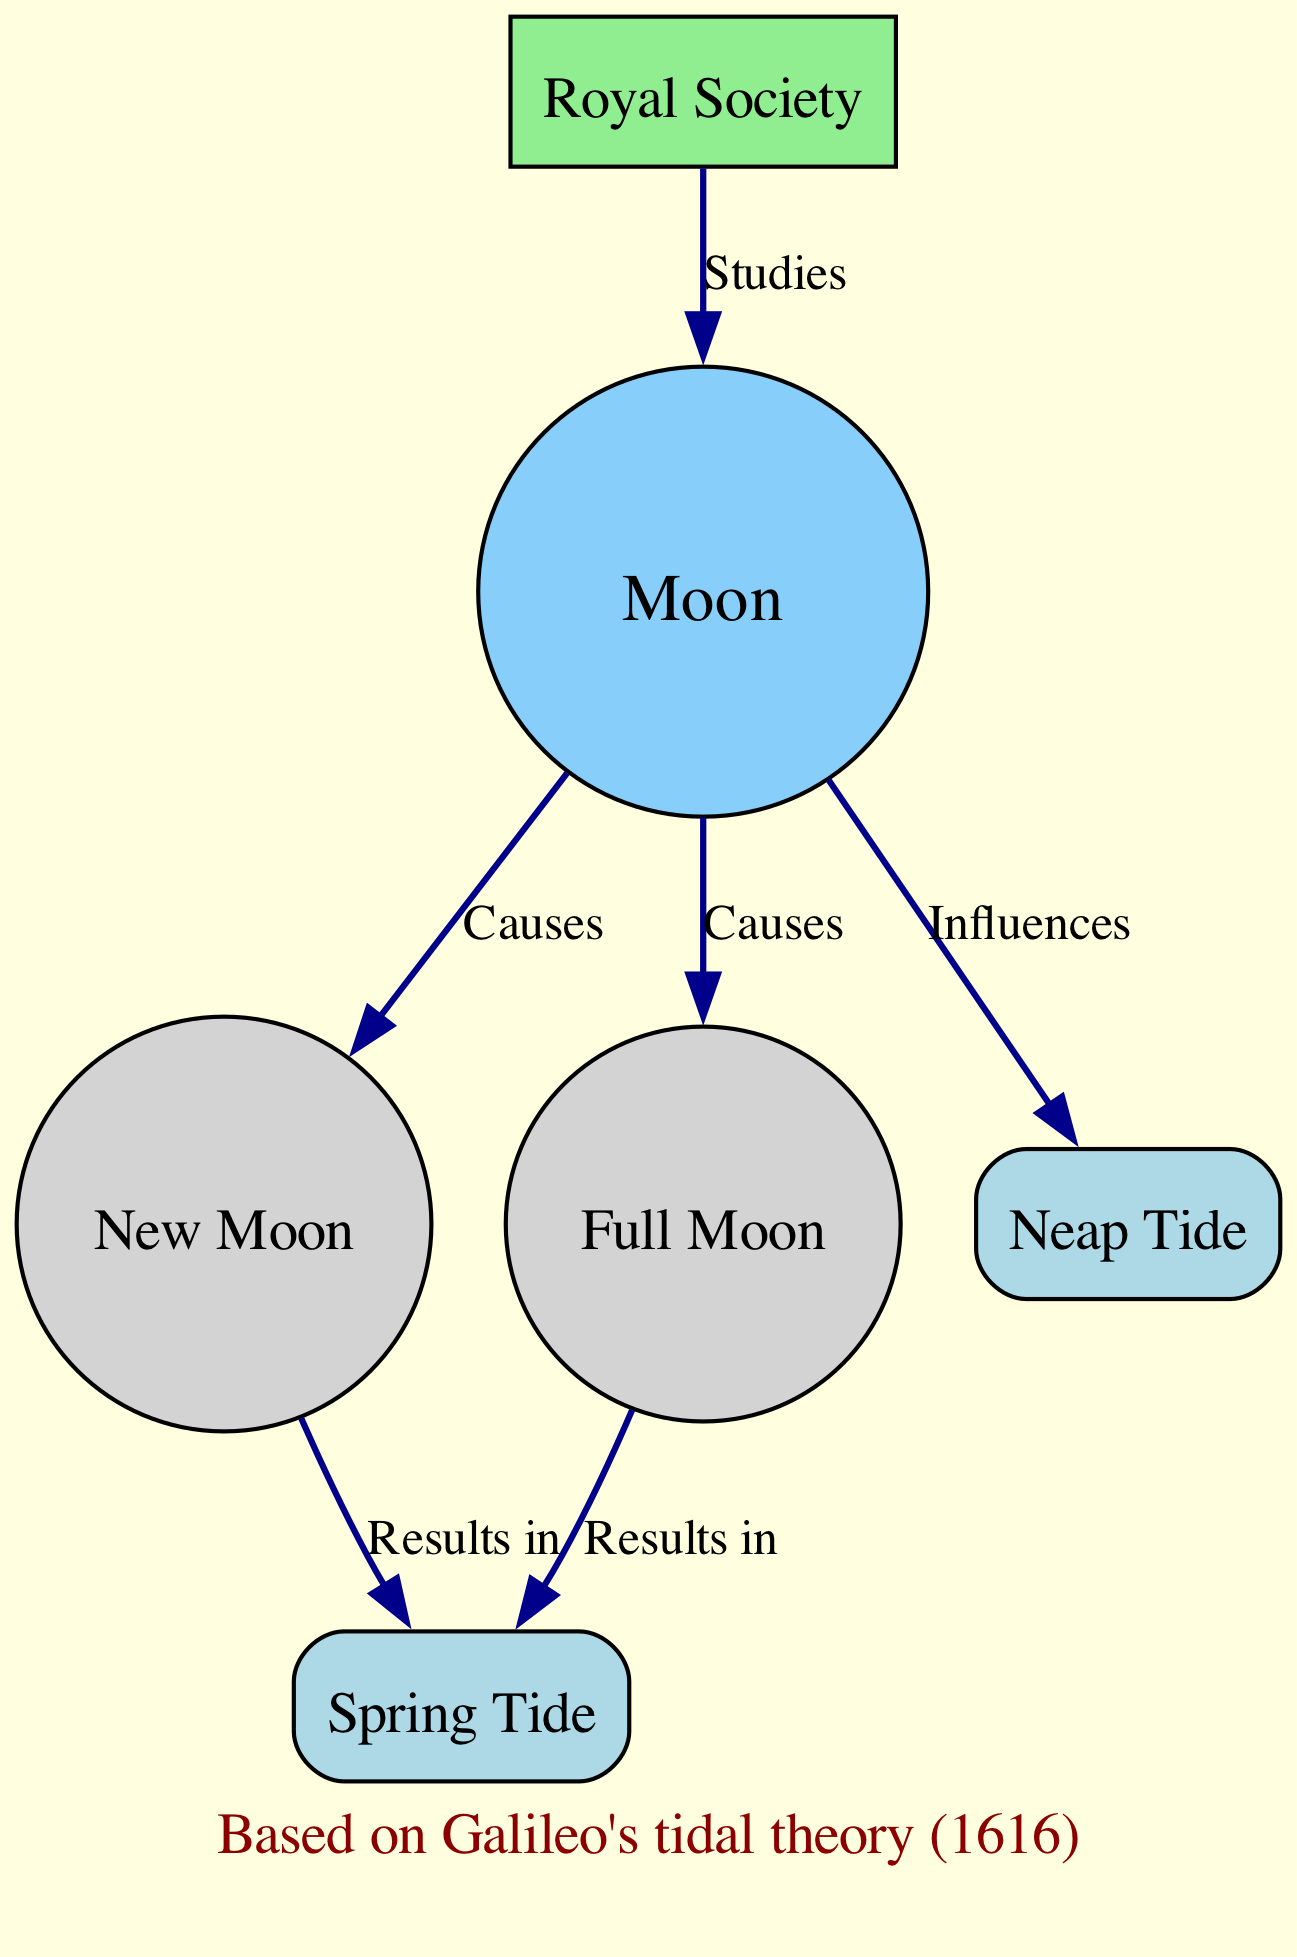What are the two types of tides represented in the diagram? The diagram includes two types of tides: spring tide and neap tide. These are specifically labeled as separate nodes in the diagram, making them easily identifiable.
Answer: spring tide, neap tide How many nodes are there in the diagram? The diagram consists of a total of six nodes: Moon, New Moon, Full Moon, Spring Tide, Neap Tide, and Royal Society. This can be counted directly from the node entries in the diagram data.
Answer: 6 Which moon phase results in spring tides? The diagram shows that both the new moon and the full moon result in spring tides, as indicated by the connections from these phases to the spring tide node.
Answer: new moon, full moon What does the Royal Society study according to the diagram? According to the diagram, the Royal Society studies the moon. This is reflected by the connection indicating that the Royal Society conducts studies related to the Moon node.
Answer: moon How does the new moon affect tides? The diagram illustrates that the new moon causes spring tides, establishing a clear cause-and-effect relationship between the new moon and the resulting tidal conditions.
Answer: results in spring tide What is the significance of the annotation regarding Galileo's tidal theory? The annotation indicates that the understanding of lunar influence on tides is based on Galileo's tidal theory established in 1616, highlighting the historical context of the diagram's information.
Answer: Based on Galileo's tidal theory (1616) Which phases of the moon influence neap tides? The diagram indicates that the moon influences neap tides, but it does not specify particular phases for neap tides; it simply connects the moon as an influencing factor.
Answer: moon 